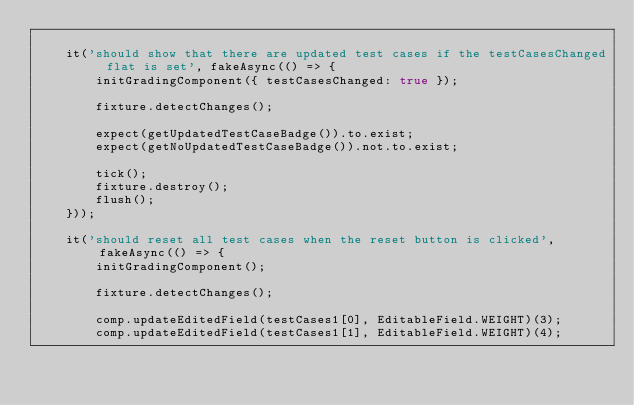Convert code to text. <code><loc_0><loc_0><loc_500><loc_500><_TypeScript_>
    it('should show that there are updated test cases if the testCasesChanged flat is set', fakeAsync(() => {
        initGradingComponent({ testCasesChanged: true });

        fixture.detectChanges();

        expect(getUpdatedTestCaseBadge()).to.exist;
        expect(getNoUpdatedTestCaseBadge()).not.to.exist;

        tick();
        fixture.destroy();
        flush();
    }));

    it('should reset all test cases when the reset button is clicked', fakeAsync(() => {
        initGradingComponent();

        fixture.detectChanges();

        comp.updateEditedField(testCases1[0], EditableField.WEIGHT)(3);
        comp.updateEditedField(testCases1[1], EditableField.WEIGHT)(4);
</code> 